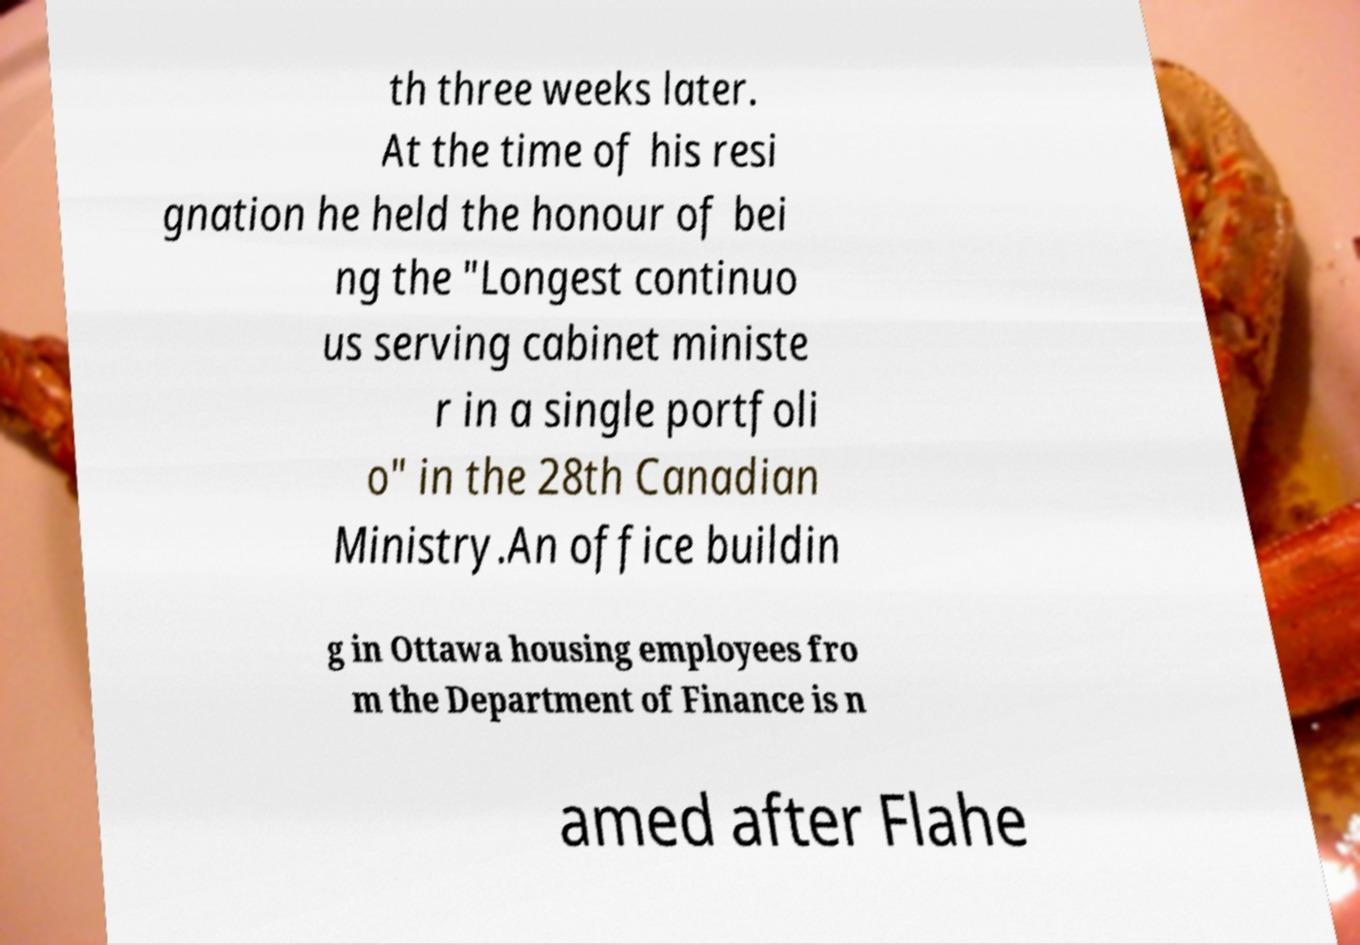Can you read and provide the text displayed in the image?This photo seems to have some interesting text. Can you extract and type it out for me? th three weeks later. At the time of his resi gnation he held the honour of bei ng the "Longest continuo us serving cabinet ministe r in a single portfoli o" in the 28th Canadian Ministry.An office buildin g in Ottawa housing employees fro m the Department of Finance is n amed after Flahe 